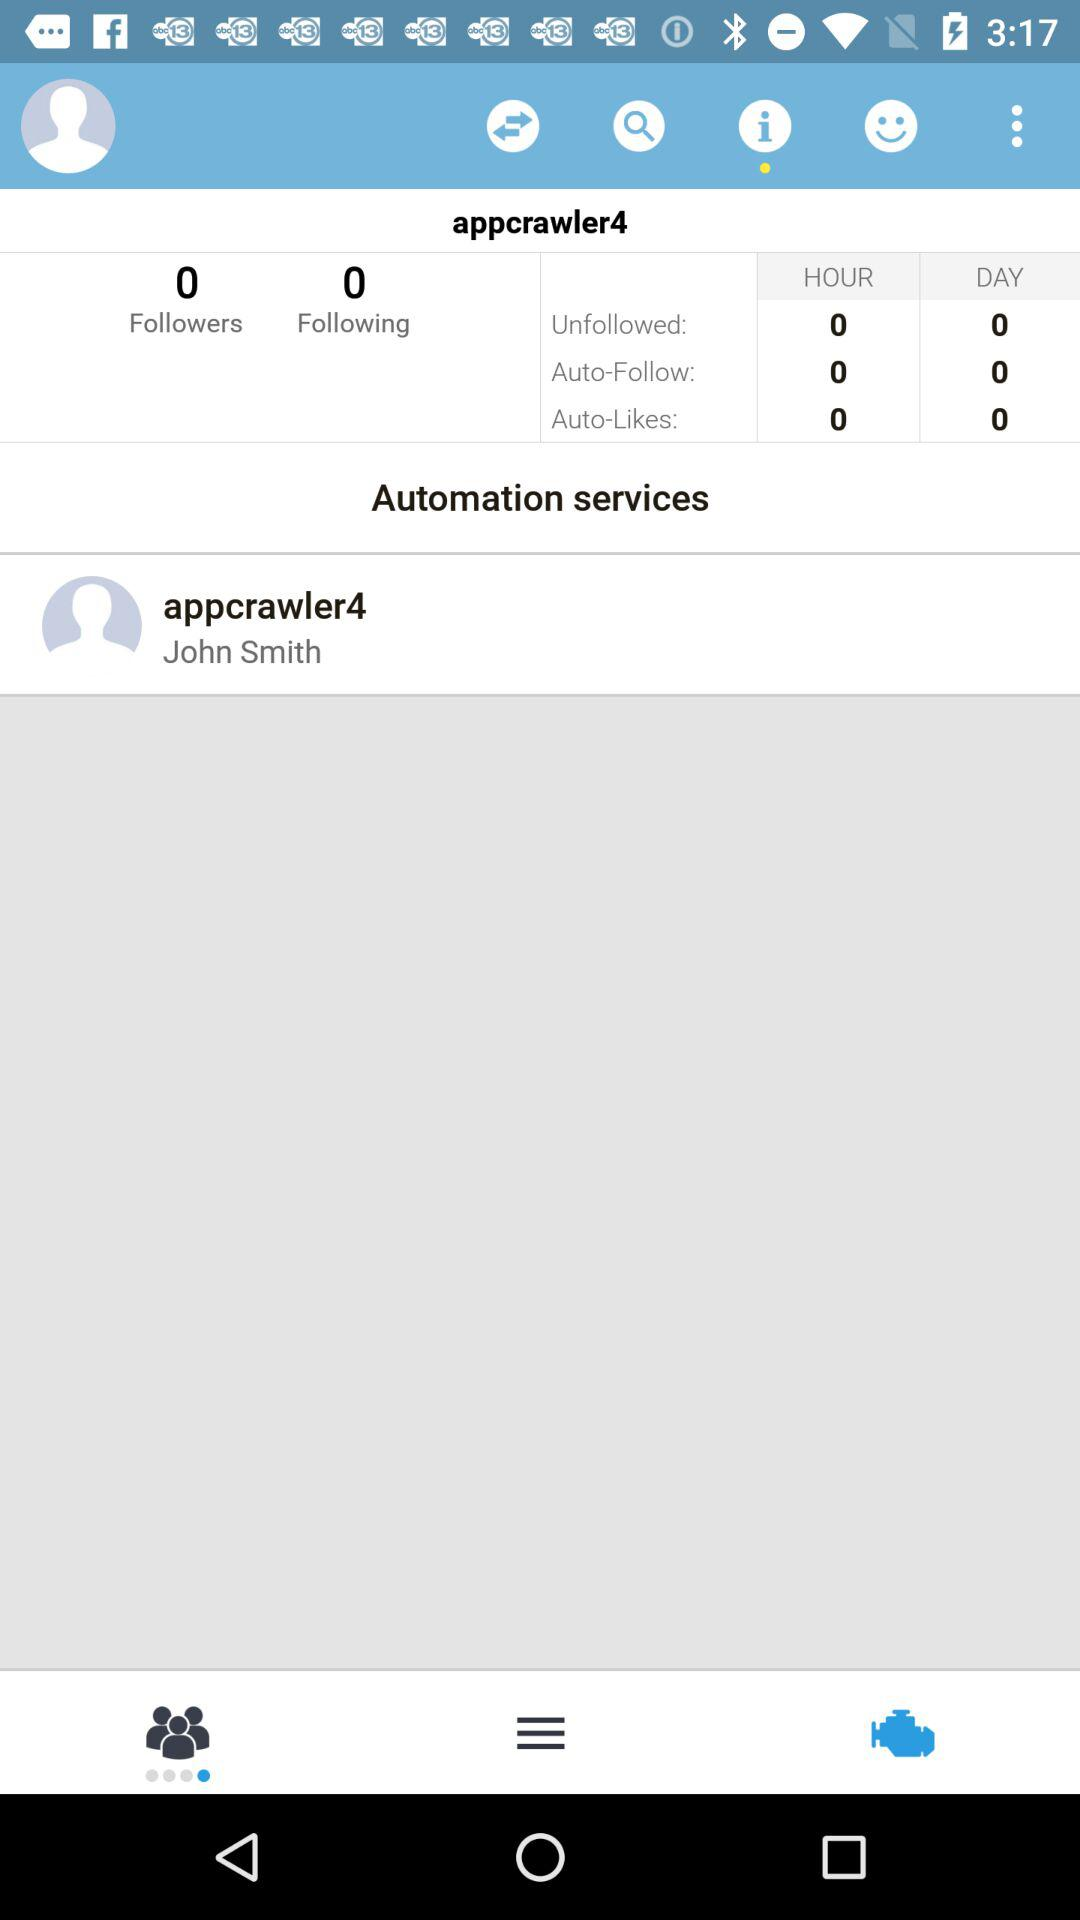What is the number of "Auto-Follow" in an hour? The number of "Auto-Follow" in an hour is 0. 